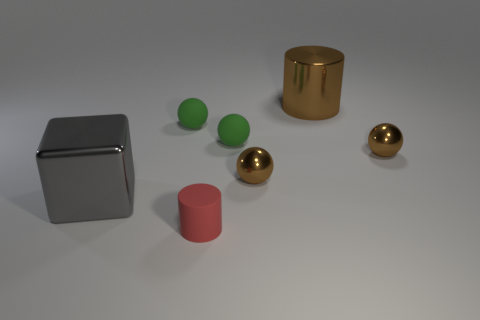Add 2 green things. How many objects exist? 9 Subtract all balls. How many objects are left? 3 Add 1 big brown metal cylinders. How many big brown metal cylinders are left? 2 Add 4 metal objects. How many metal objects exist? 8 Subtract 0 brown cubes. How many objects are left? 7 Subtract all small purple rubber cylinders. Subtract all tiny red cylinders. How many objects are left? 6 